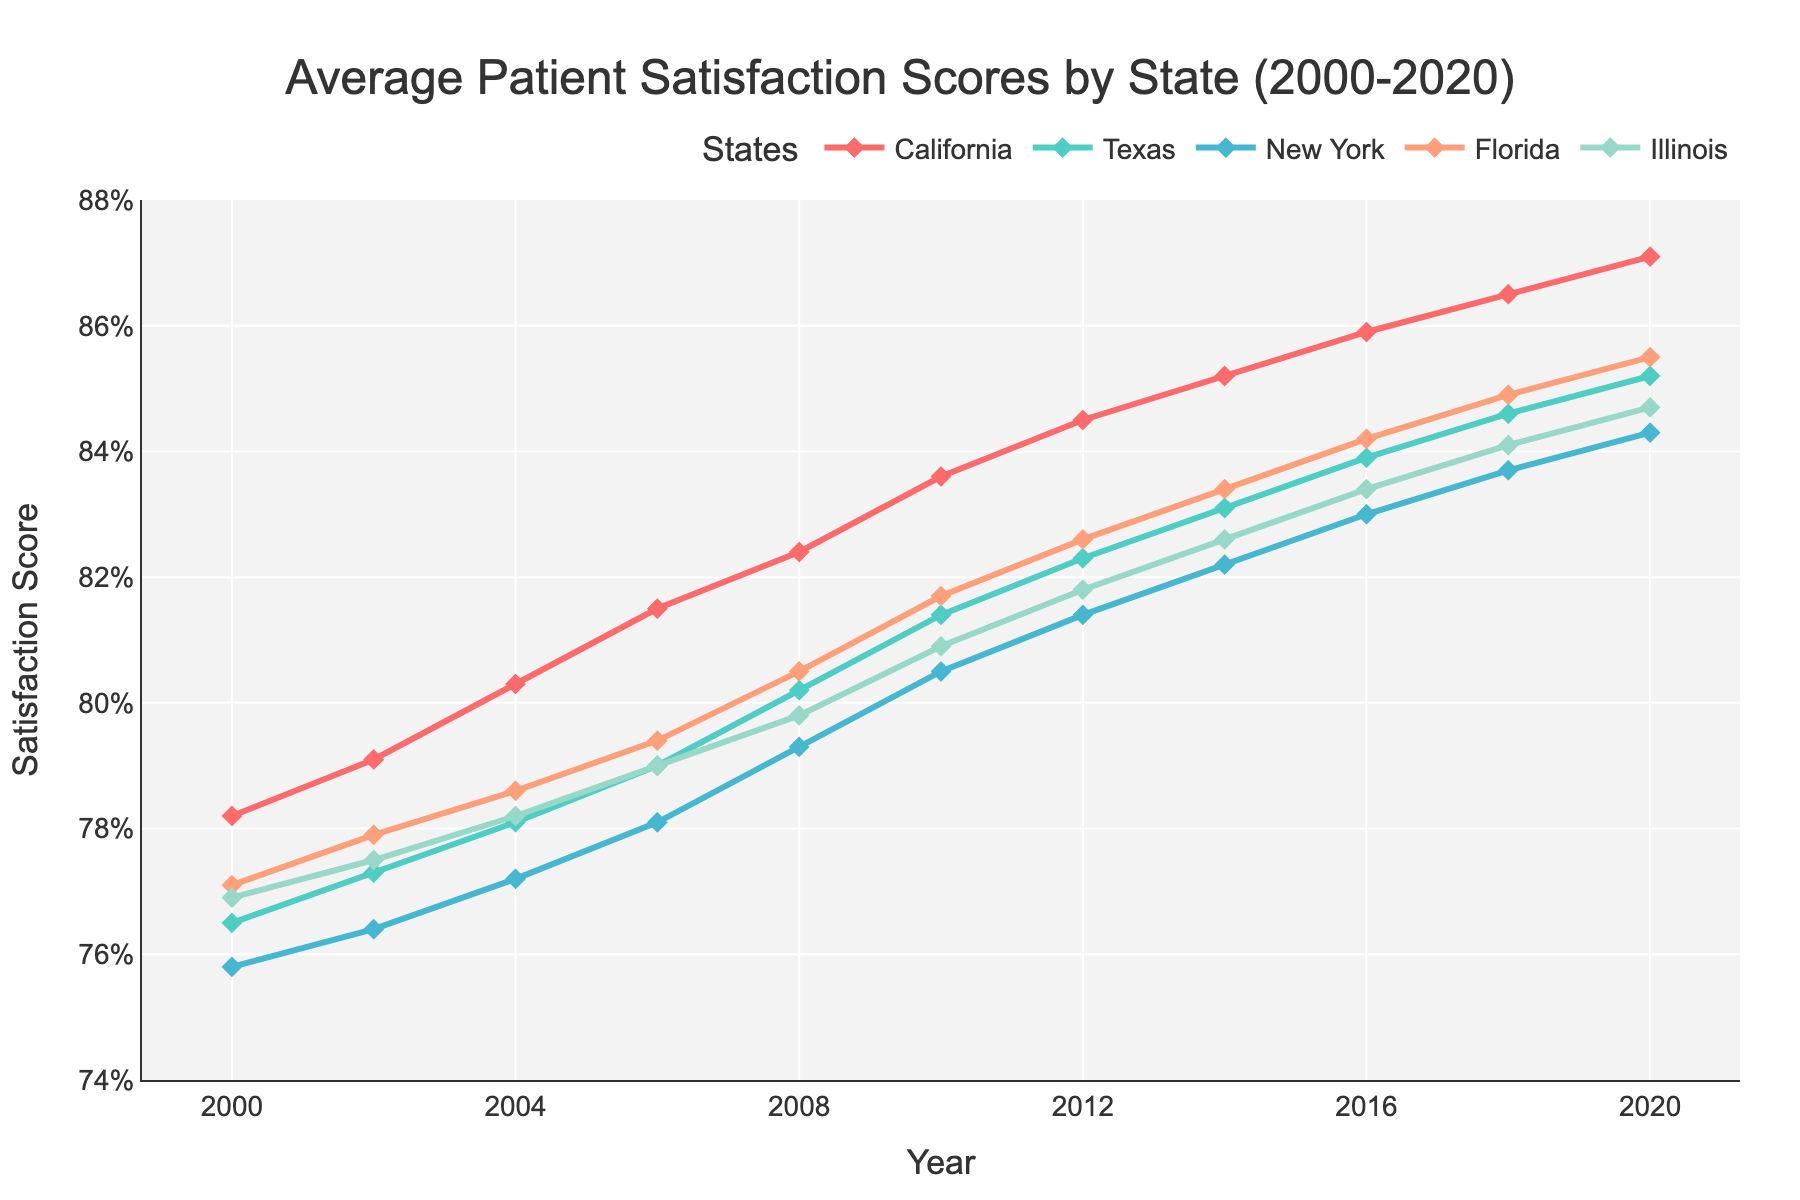What is the average satisfaction score for California from 2000 to 2020? The yearly satisfaction scores for California are 78.2, 79.1, 80.3, 81.5, 82.4, 83.6, 84.5, 85.2, 85.9, 86.5, and 87.1. Summing these values gives 934.3. There are 11 data points, so dividing the sum by 11 gives the average: 934.3/11 = 84.94
Answer: 84.94 Which state had the highest satisfaction score in 2020? By visually inspecting the line chart for the year 2020, we observe the ending points of the lines. The highest point corresponds to California with a score of 87.1
Answer: California Between 2004 and 2010, which state showed the greatest improvement in satisfaction scores? Calculating the difference from 2004 to 2010 for each state: 
- California: 83.6 - 80.3 = 3.3
- Texas: 81.4 - 78.1 = 3.3
- New York: 80.5 - 77.2 = 3.3
- Florida: 81.7 - 78.6 = 3.1
- Illinois: 80.9 - 78.2 = 2.7
All three states California, Texas, and New York show the greatest improvement of 3.3 points
Answer: California, Texas, and New York What is the trend of satisfaction scores for Florida from 2000 to 2020? The satisfaction scores for Florida are 77.1, 77.9, 78.6, 79.4, 80.5, 81.7, 82.6, 83.4, 84.2, 84.9, and 85.5 from 2000 to 2020, respectively. The trend is consistently increasing without any decrease.
Answer: Increasing Which state had the lowest average satisfaction score over the entire period from 2000 to 2020? Calculating average scores for each state:
- California: 84.94 (as previously calculated)
- Texas: Sum = 76.5 + 77.3 + 78.1 + 79.0 + 80.2 + 81.4 + 82.3 + 83.1 + 83.9 + 84.6 + 85.2 = 891.6; Average = 891.6/11 = 81.05
- New York: Sum = 75.8 + 76.4 + 77.2 + 78.1 + 79.3 + 80.5 + 81.4 + 82.2 + 83.0 + 83.7 + 84.3 = 841.9; Average = 841.9/11 = 76.54
- Florida: Sum = 77.1 + 77.9 + 78.6 + 79.4 + 80.5 + 81.7 + 82.6 + 83.4 + 84.2 + 84.9 + 85.5 = 895.8; Average = 895.8/11 = 81.44
- Illinois: Sum = 76.9 + 77.5 + 78.2 + 79.0 + 79.8 + 80.9 + 81.8 + 82.6 + 83.4 + 84.1 + 84.7 = 889.9; Average = 889.9/11 = 80.81
New York has the lowest average satisfaction score at 76.54.
Answer: New York 